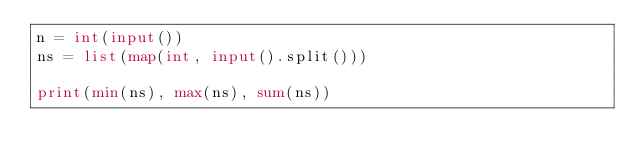Convert code to text. <code><loc_0><loc_0><loc_500><loc_500><_Python_>n = int(input())
ns = list(map(int, input().split()))

print(min(ns), max(ns), sum(ns))
</code> 